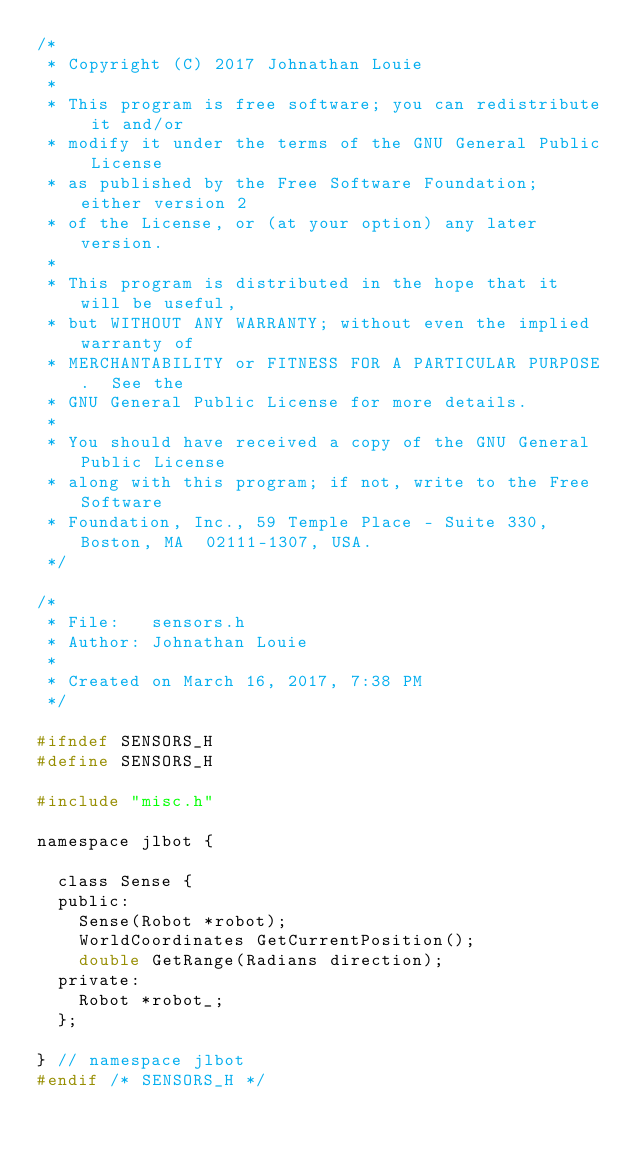Convert code to text. <code><loc_0><loc_0><loc_500><loc_500><_C_>/*
 * Copyright (C) 2017 Johnathan Louie
 *
 * This program is free software; you can redistribute it and/or
 * modify it under the terms of the GNU General Public License
 * as published by the Free Software Foundation; either version 2
 * of the License, or (at your option) any later version.
 *
 * This program is distributed in the hope that it will be useful,
 * but WITHOUT ANY WARRANTY; without even the implied warranty of
 * MERCHANTABILITY or FITNESS FOR A PARTICULAR PURPOSE.  See the
 * GNU General Public License for more details.
 *
 * You should have received a copy of the GNU General Public License
 * along with this program; if not, write to the Free Software
 * Foundation, Inc., 59 Temple Place - Suite 330, Boston, MA  02111-1307, USA.
 */

/*
 * File:   sensors.h
 * Author: Johnathan Louie
 *
 * Created on March 16, 2017, 7:38 PM
 */

#ifndef SENSORS_H
#define SENSORS_H

#include "misc.h"

namespace jlbot {

  class Sense {
  public:
    Sense(Robot *robot);
    WorldCoordinates GetCurrentPosition();
    double GetRange(Radians direction);
  private:
    Robot *robot_;
  };

} // namespace jlbot
#endif /* SENSORS_H */
</code> 